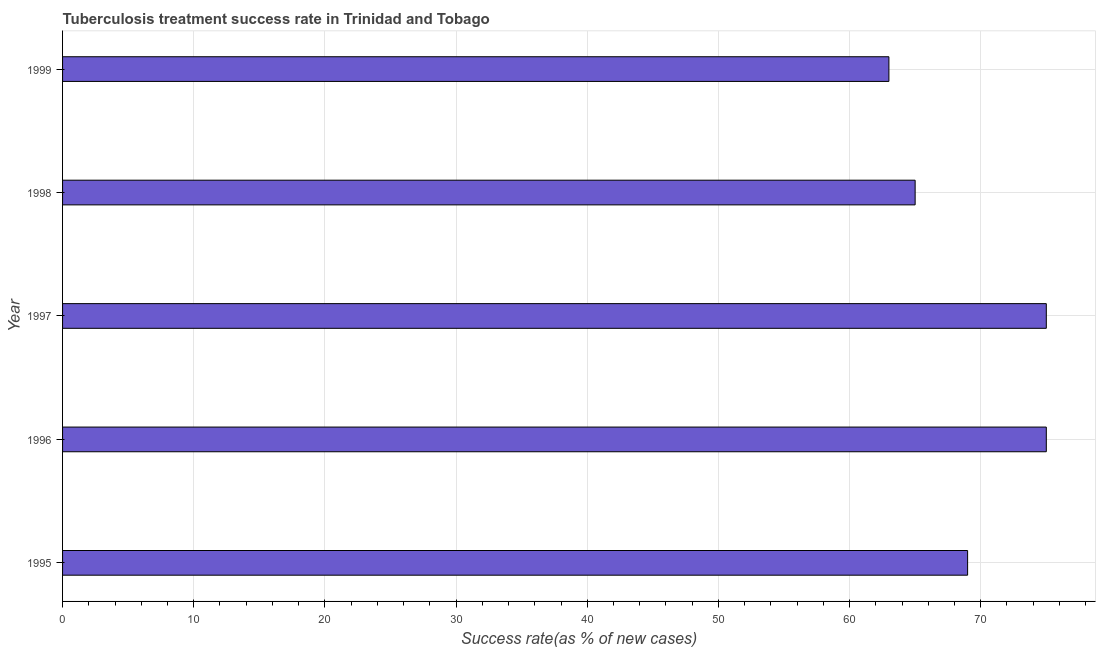Does the graph contain any zero values?
Keep it short and to the point. No. Does the graph contain grids?
Give a very brief answer. Yes. What is the title of the graph?
Provide a short and direct response. Tuberculosis treatment success rate in Trinidad and Tobago. What is the label or title of the X-axis?
Provide a succinct answer. Success rate(as % of new cases). What is the label or title of the Y-axis?
Provide a succinct answer. Year. Across all years, what is the maximum tuberculosis treatment success rate?
Offer a very short reply. 75. Across all years, what is the minimum tuberculosis treatment success rate?
Keep it short and to the point. 63. What is the sum of the tuberculosis treatment success rate?
Your answer should be compact. 347. What is the difference between the tuberculosis treatment success rate in 1996 and 1997?
Your answer should be very brief. 0. In how many years, is the tuberculosis treatment success rate greater than 36 %?
Provide a succinct answer. 5. Do a majority of the years between 1998 and 1996 (inclusive) have tuberculosis treatment success rate greater than 64 %?
Your answer should be compact. Yes. What is the ratio of the tuberculosis treatment success rate in 1996 to that in 1997?
Provide a succinct answer. 1. Is the tuberculosis treatment success rate in 1996 less than that in 1999?
Offer a very short reply. No. What is the difference between the highest and the second highest tuberculosis treatment success rate?
Offer a very short reply. 0. What is the difference between the highest and the lowest tuberculosis treatment success rate?
Your answer should be very brief. 12. How many years are there in the graph?
Provide a succinct answer. 5. What is the difference between two consecutive major ticks on the X-axis?
Offer a very short reply. 10. Are the values on the major ticks of X-axis written in scientific E-notation?
Your answer should be very brief. No. What is the Success rate(as % of new cases) of 1995?
Give a very brief answer. 69. What is the Success rate(as % of new cases) in 1996?
Ensure brevity in your answer.  75. What is the Success rate(as % of new cases) of 1997?
Offer a very short reply. 75. What is the Success rate(as % of new cases) of 1999?
Provide a succinct answer. 63. What is the difference between the Success rate(as % of new cases) in 1995 and 1996?
Your answer should be very brief. -6. What is the difference between the Success rate(as % of new cases) in 1995 and 1999?
Your answer should be very brief. 6. What is the difference between the Success rate(as % of new cases) in 1996 and 1998?
Provide a short and direct response. 10. What is the ratio of the Success rate(as % of new cases) in 1995 to that in 1998?
Make the answer very short. 1.06. What is the ratio of the Success rate(as % of new cases) in 1995 to that in 1999?
Your answer should be compact. 1.09. What is the ratio of the Success rate(as % of new cases) in 1996 to that in 1997?
Provide a short and direct response. 1. What is the ratio of the Success rate(as % of new cases) in 1996 to that in 1998?
Keep it short and to the point. 1.15. What is the ratio of the Success rate(as % of new cases) in 1996 to that in 1999?
Offer a very short reply. 1.19. What is the ratio of the Success rate(as % of new cases) in 1997 to that in 1998?
Ensure brevity in your answer.  1.15. What is the ratio of the Success rate(as % of new cases) in 1997 to that in 1999?
Offer a very short reply. 1.19. What is the ratio of the Success rate(as % of new cases) in 1998 to that in 1999?
Make the answer very short. 1.03. 